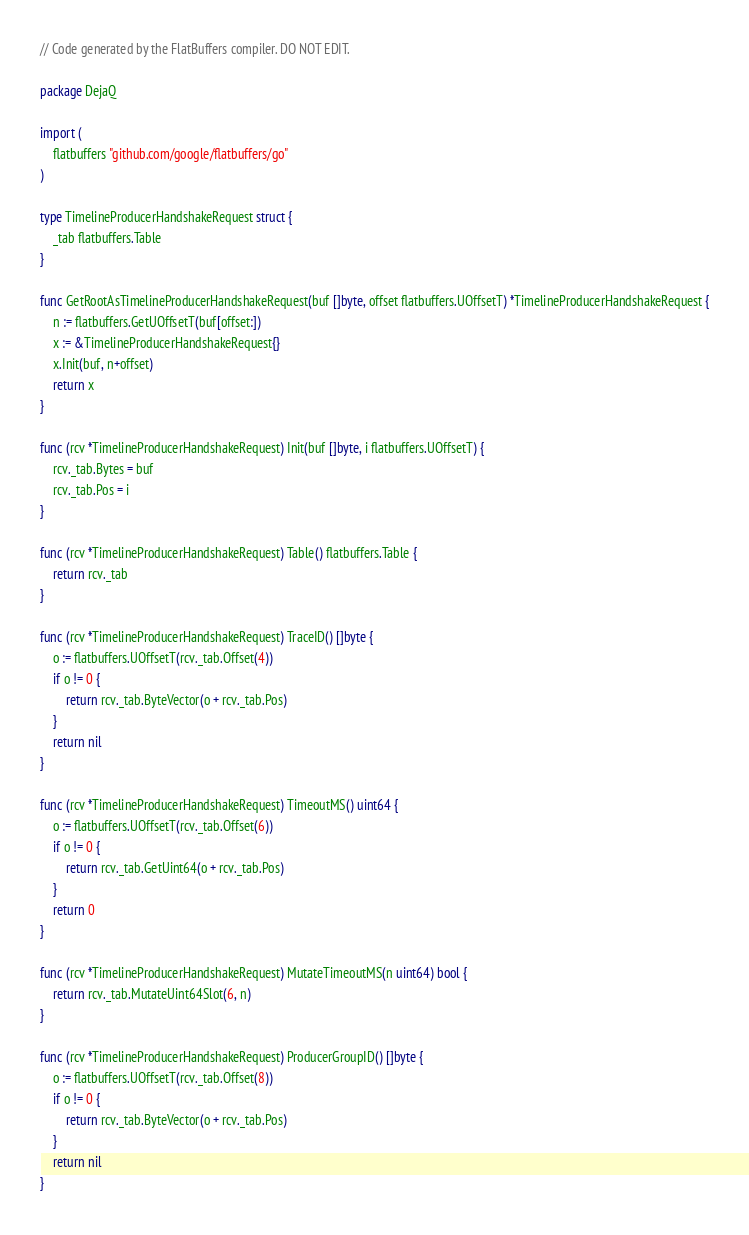Convert code to text. <code><loc_0><loc_0><loc_500><loc_500><_Go_>// Code generated by the FlatBuffers compiler. DO NOT EDIT.

package DejaQ

import (
	flatbuffers "github.com/google/flatbuffers/go"
)

type TimelineProducerHandshakeRequest struct {
	_tab flatbuffers.Table
}

func GetRootAsTimelineProducerHandshakeRequest(buf []byte, offset flatbuffers.UOffsetT) *TimelineProducerHandshakeRequest {
	n := flatbuffers.GetUOffsetT(buf[offset:])
	x := &TimelineProducerHandshakeRequest{}
	x.Init(buf, n+offset)
	return x
}

func (rcv *TimelineProducerHandshakeRequest) Init(buf []byte, i flatbuffers.UOffsetT) {
	rcv._tab.Bytes = buf
	rcv._tab.Pos = i
}

func (rcv *TimelineProducerHandshakeRequest) Table() flatbuffers.Table {
	return rcv._tab
}

func (rcv *TimelineProducerHandshakeRequest) TraceID() []byte {
	o := flatbuffers.UOffsetT(rcv._tab.Offset(4))
	if o != 0 {
		return rcv._tab.ByteVector(o + rcv._tab.Pos)
	}
	return nil
}

func (rcv *TimelineProducerHandshakeRequest) TimeoutMS() uint64 {
	o := flatbuffers.UOffsetT(rcv._tab.Offset(6))
	if o != 0 {
		return rcv._tab.GetUint64(o + rcv._tab.Pos)
	}
	return 0
}

func (rcv *TimelineProducerHandshakeRequest) MutateTimeoutMS(n uint64) bool {
	return rcv._tab.MutateUint64Slot(6, n)
}

func (rcv *TimelineProducerHandshakeRequest) ProducerGroupID() []byte {
	o := flatbuffers.UOffsetT(rcv._tab.Offset(8))
	if o != 0 {
		return rcv._tab.ByteVector(o + rcv._tab.Pos)
	}
	return nil
}
</code> 